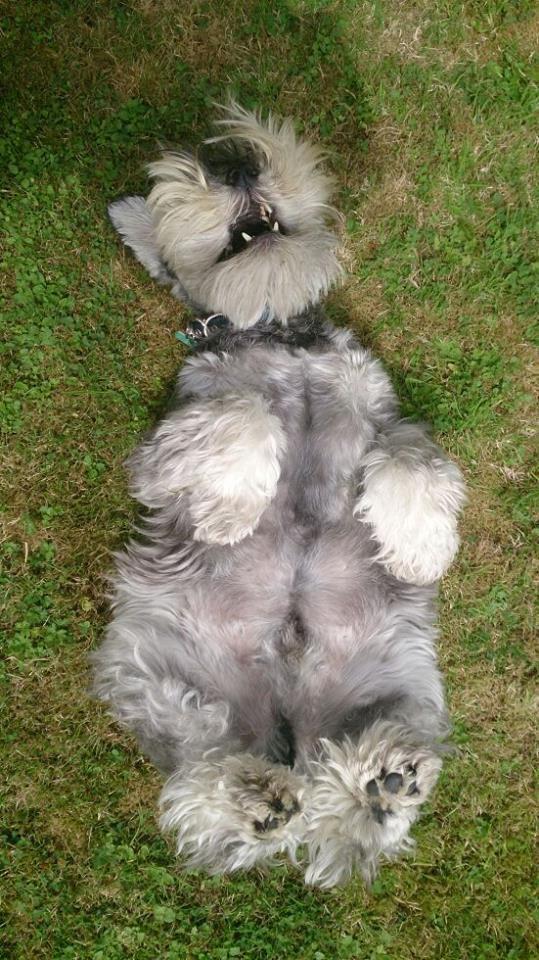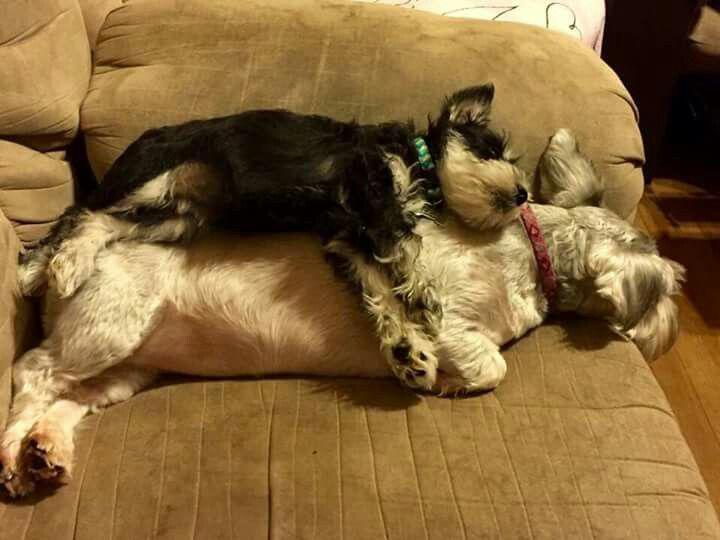The first image is the image on the left, the second image is the image on the right. For the images displayed, is the sentence "There is an all white dog laying down." factually correct? Answer yes or no. Yes. The first image is the image on the left, the second image is the image on the right. Given the left and right images, does the statement "A dog is sitting in one picture and in the other picture ta dog is lying down and asleep." hold true? Answer yes or no. No. 